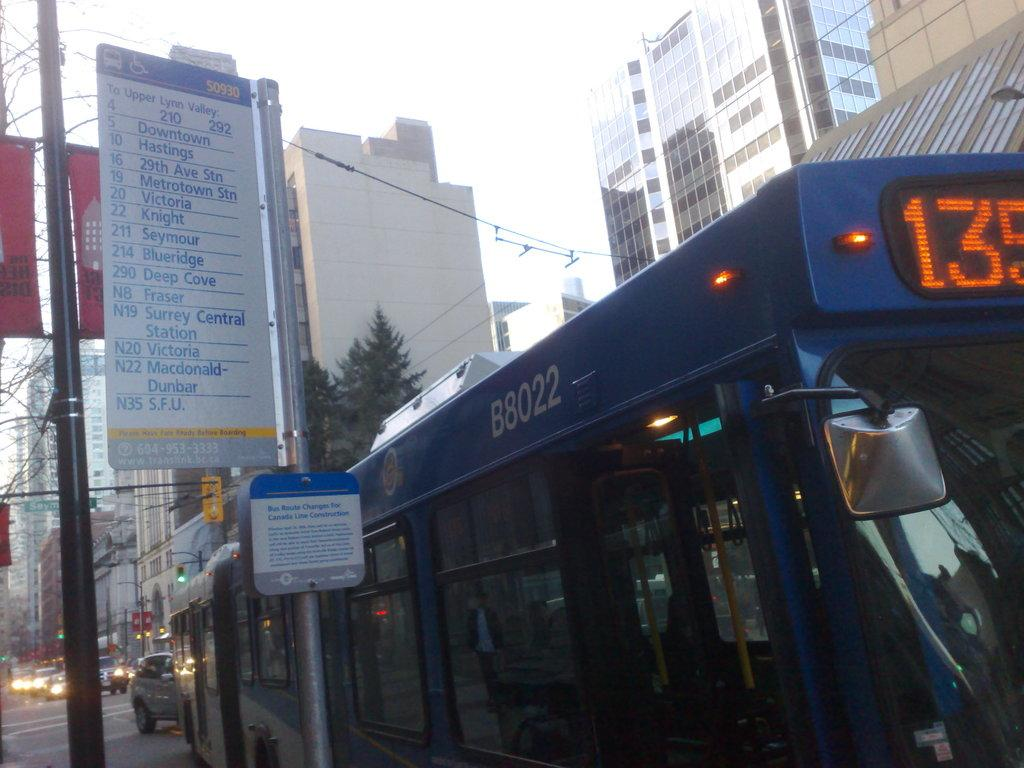<image>
Provide a brief description of the given image. A blue bus with tall buildings surrounded it and the number 135 on top of the bus. 